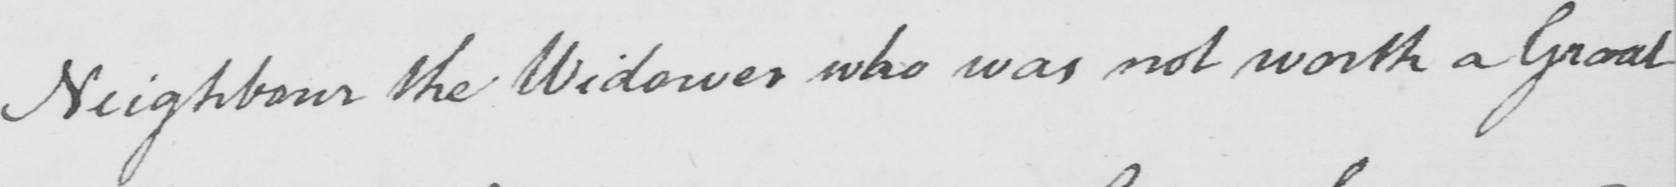Can you read and transcribe this handwriting? Neighbour the Widower who was not worth a Groat 